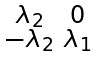<formula> <loc_0><loc_0><loc_500><loc_500>\begin{smallmatrix} \lambda _ { 2 } & 0 \\ - \lambda _ { 2 } & \lambda _ { 1 } \end{smallmatrix}</formula> 